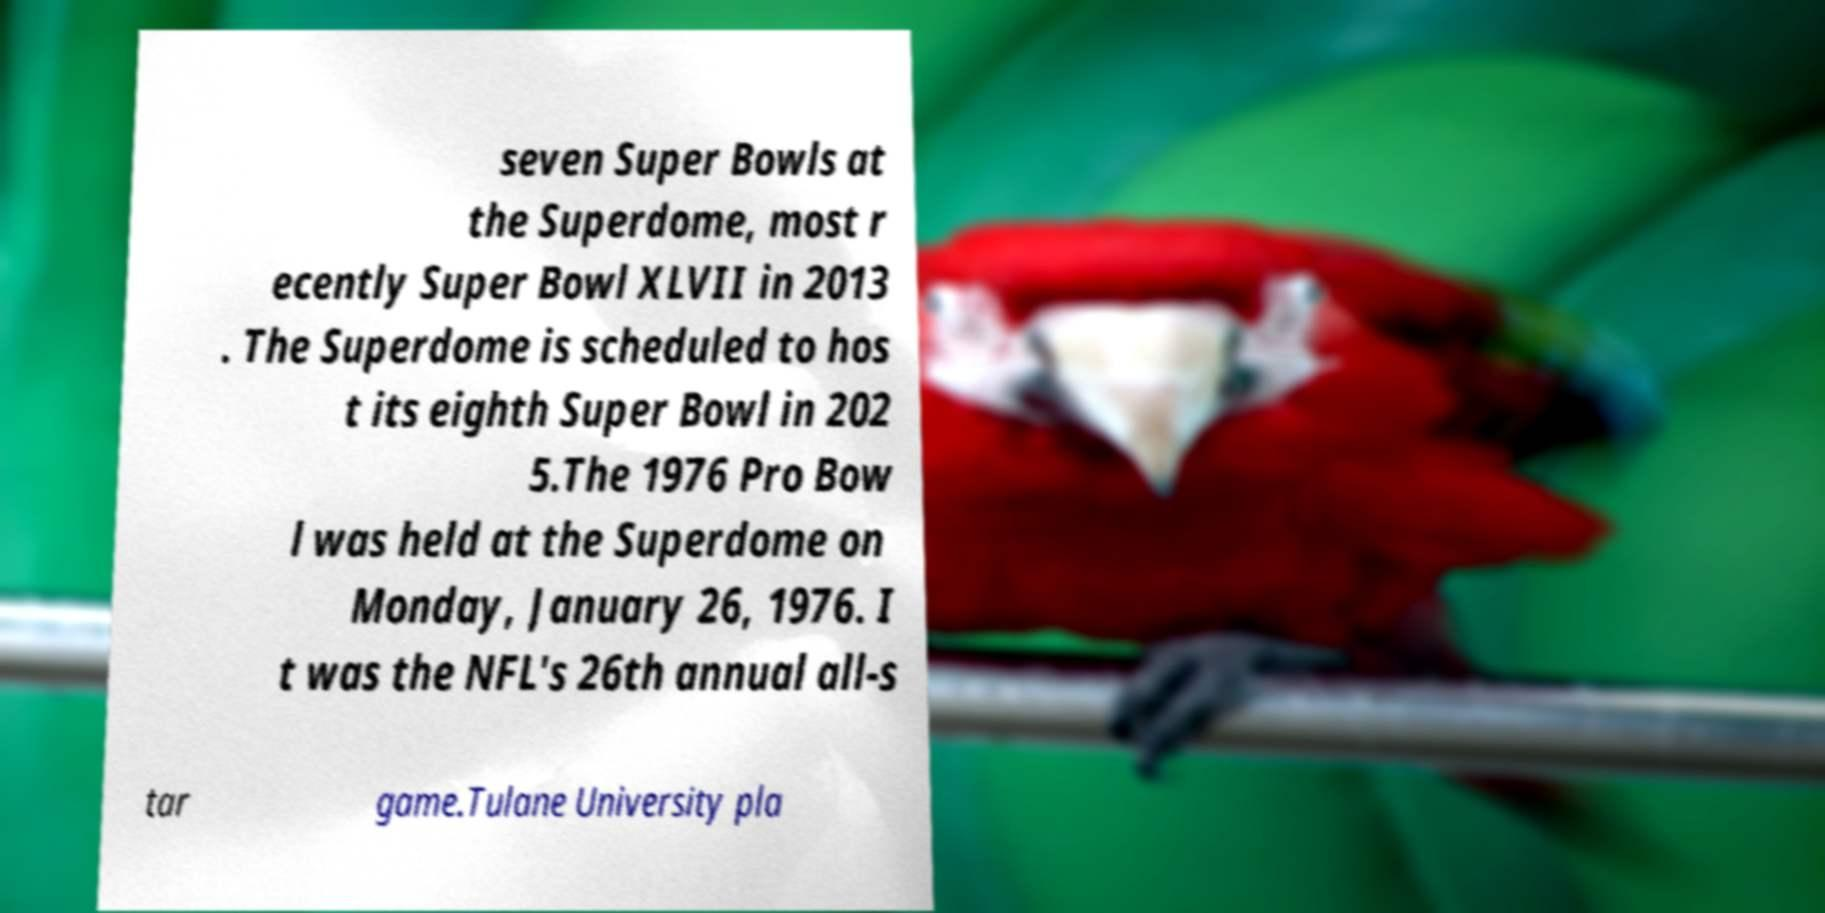For documentation purposes, I need the text within this image transcribed. Could you provide that? seven Super Bowls at the Superdome, most r ecently Super Bowl XLVII in 2013 . The Superdome is scheduled to hos t its eighth Super Bowl in 202 5.The 1976 Pro Bow l was held at the Superdome on Monday, January 26, 1976. I t was the NFL's 26th annual all-s tar game.Tulane University pla 